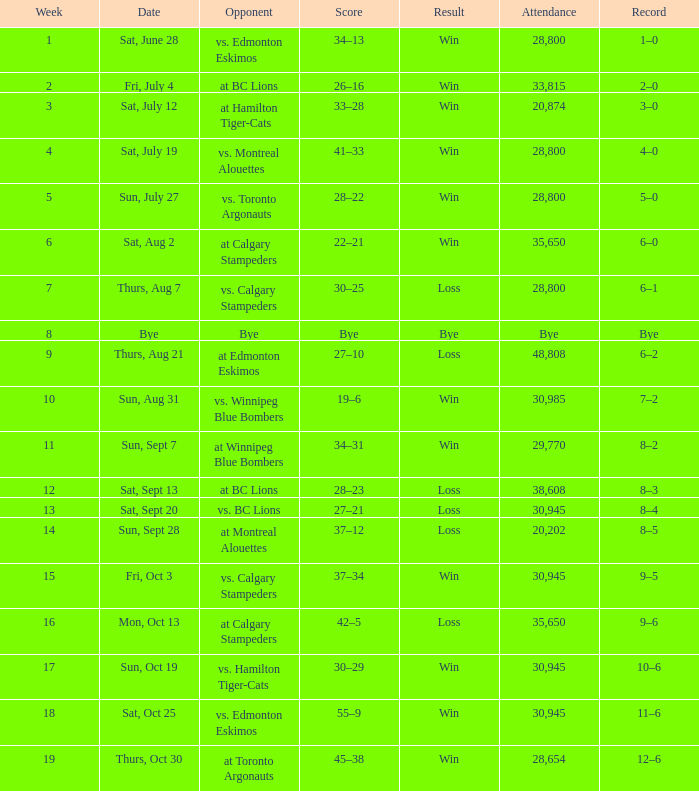What was the record the the match against vs. calgary stampeders before week 15? 6–1. 